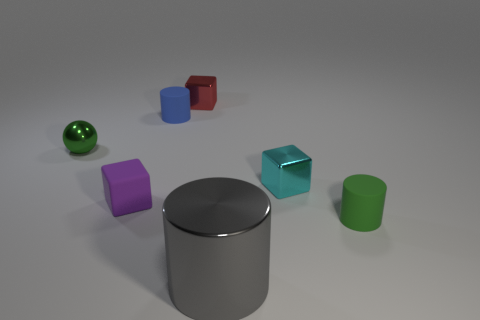Add 1 gray metallic things. How many objects exist? 8 Subtract all spheres. How many objects are left? 6 Add 6 cyan blocks. How many cyan blocks exist? 7 Subtract 0 red cylinders. How many objects are left? 7 Subtract all big gray metallic objects. Subtract all red objects. How many objects are left? 5 Add 3 big gray metallic cylinders. How many big gray metallic cylinders are left? 4 